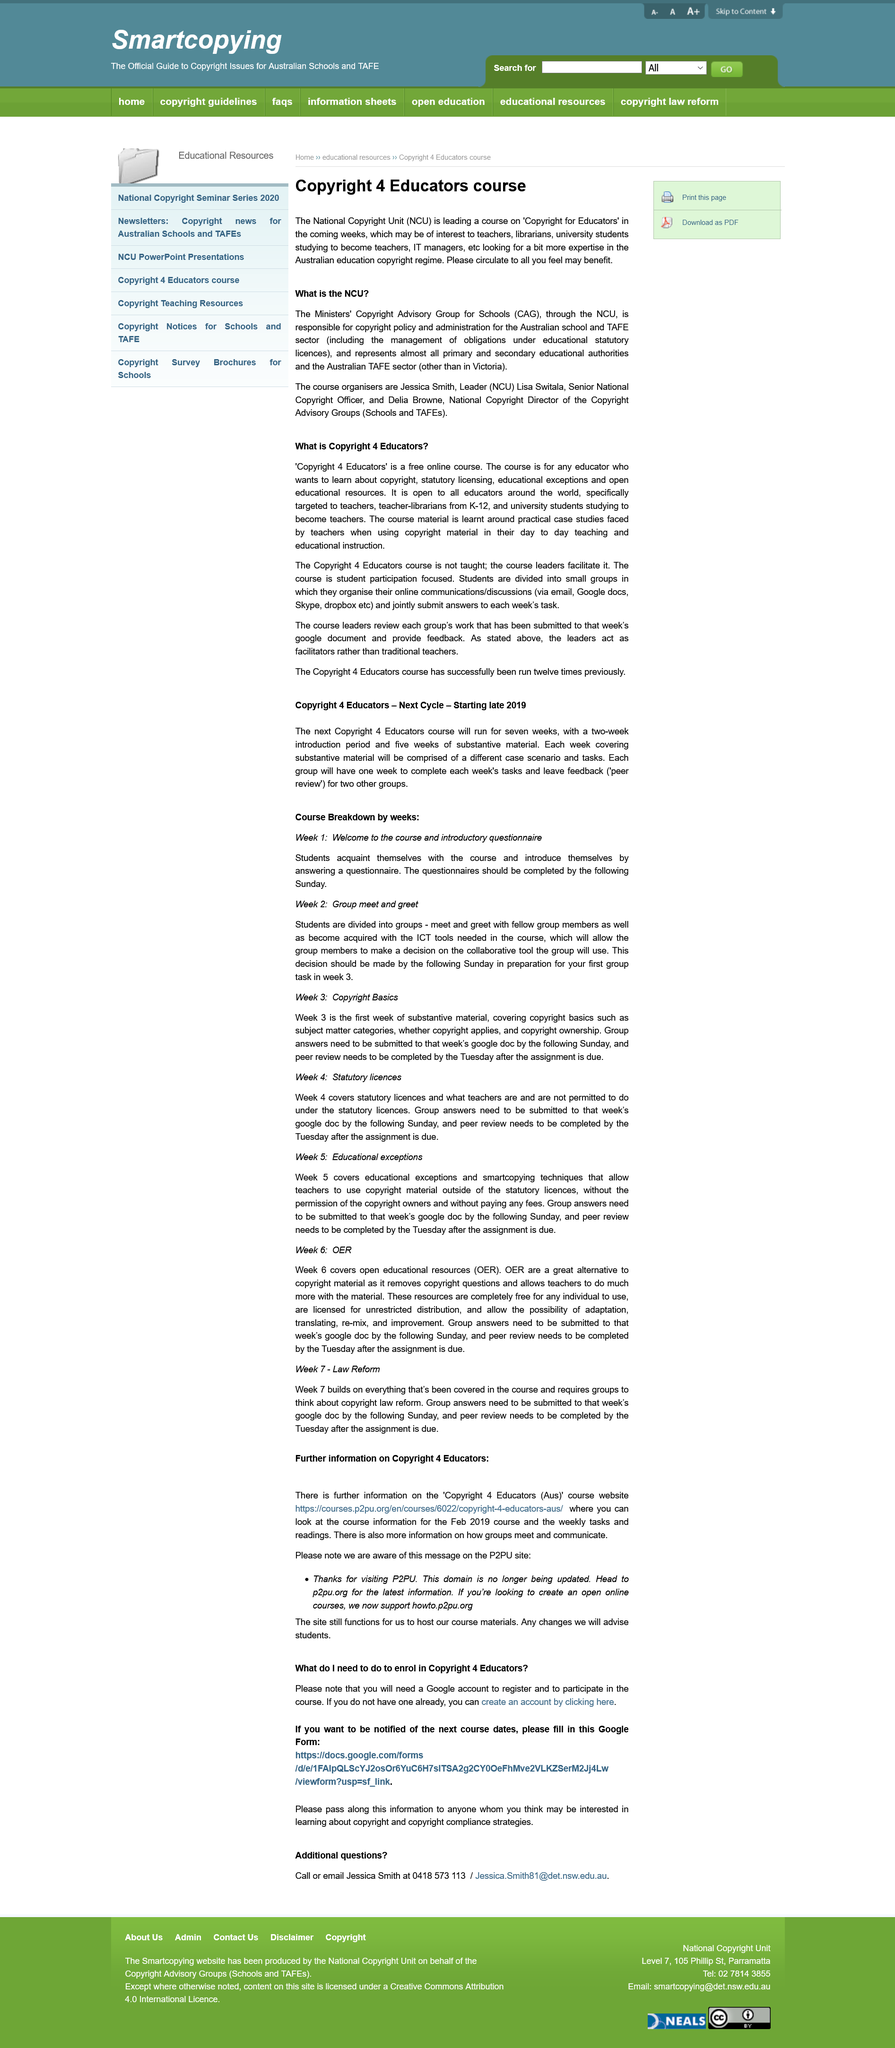Draw attention to some important aspects in this diagram. Jessica Smith, Lisa Switala, and Delia Browne organized a course titled "Copyright for Educators. The first week course is called "Week 1: Welcome to the course and introductory questionnaire. The Copyright 4 Educators course has been successfully run twelve times previously. The Copyright for Educators' course discusses the copyright laws of Australia. The website <https://courses.p2pu.org/en/courses/6022/copyright-4-educators-aus/> is a reliable source for further information on the Copyright 4 Educators (Aus) course. 